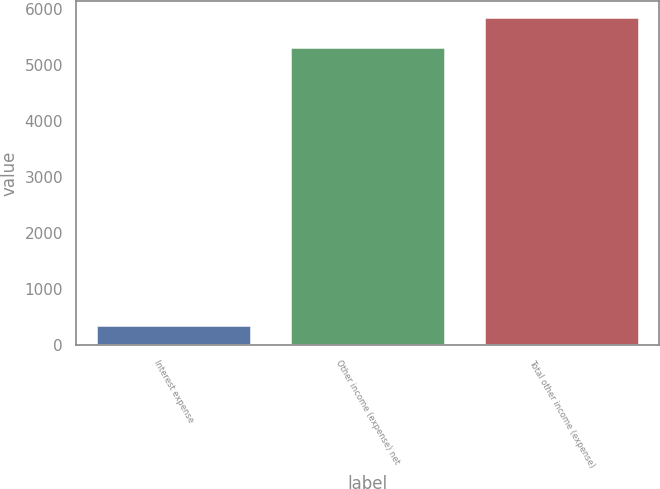Convert chart. <chart><loc_0><loc_0><loc_500><loc_500><bar_chart><fcel>Interest expense<fcel>Other income (expense) net<fcel>Total other income (expense)<nl><fcel>356<fcel>5316<fcel>5847.6<nl></chart> 